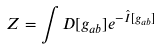Convert formula to latex. <formula><loc_0><loc_0><loc_500><loc_500>Z = \int D [ g _ { a b } ] e ^ { - \hat { I } [ g _ { a b } ] }</formula> 